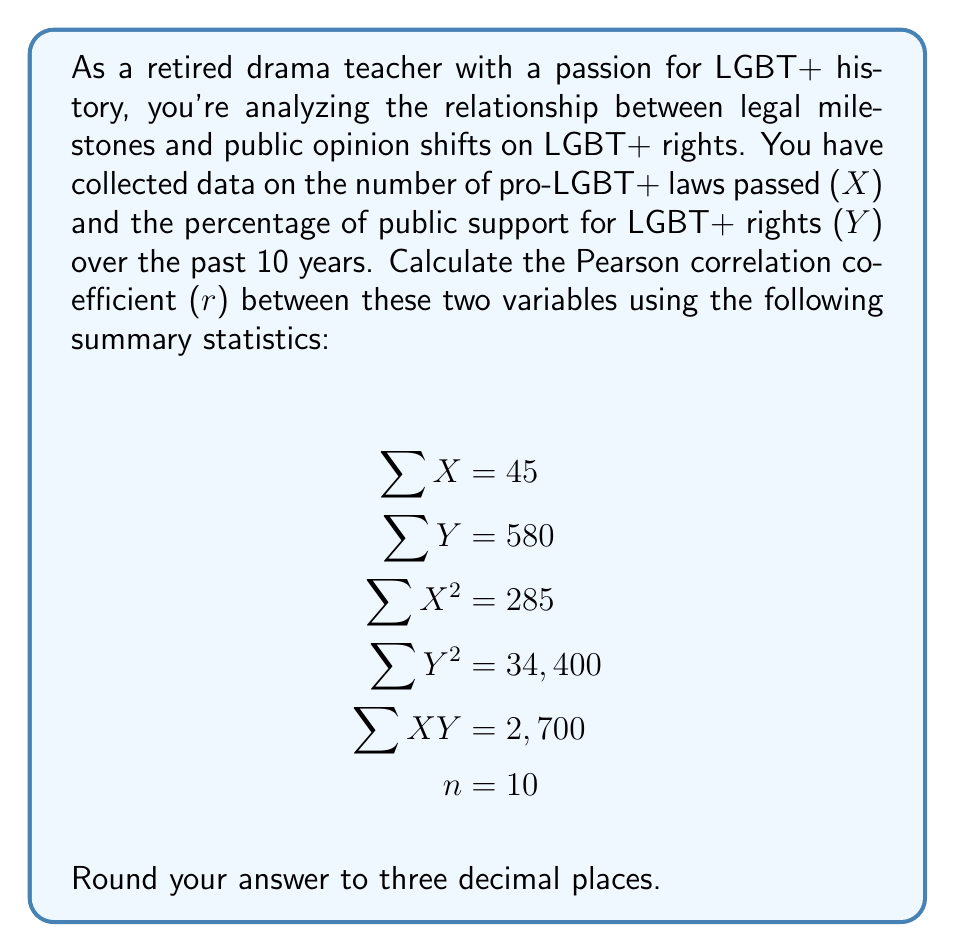Can you answer this question? To calculate the Pearson correlation coefficient (r), we'll use the formula:

$$r = \frac{n\sum XY - (\sum X)(\sum Y)}{\sqrt{[n\sum X^2 - (\sum X)^2][n\sum Y^2 - (\sum Y)^2]}}$$

Let's substitute the given values:

1. Calculate $n\sum XY$:
   $10 \times 2,700 = 27,000$

2. Calculate $(\sum X)(\sum Y)$:
   $45 \times 580 = 26,100$

3. Calculate $n\sum X^2$:
   $10 \times 285 = 2,850$

4. Calculate $(\sum X)^2$:
   $45^2 = 2,025$

5. Calculate $n\sum Y^2$:
   $10 \times 34,400 = 344,000$

6. Calculate $(\sum Y)^2$:
   $580^2 = 336,400$

Now, let's plug these values into the formula:

$$r = \frac{27,000 - 26,100}{\sqrt{[2,850 - 2,025][344,000 - 336,400]}}$$

$$r = \frac{900}{\sqrt{825 \times 7,600}}$$

$$r = \frac{900}{\sqrt{6,270,000}}$$

$$r = \frac{900}{2,503.996}$$

$$r = 0.359426$$

Rounding to three decimal places:

$$r \approx 0.359$$
Answer: 0.359 